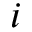<formula> <loc_0><loc_0><loc_500><loc_500>i</formula> 